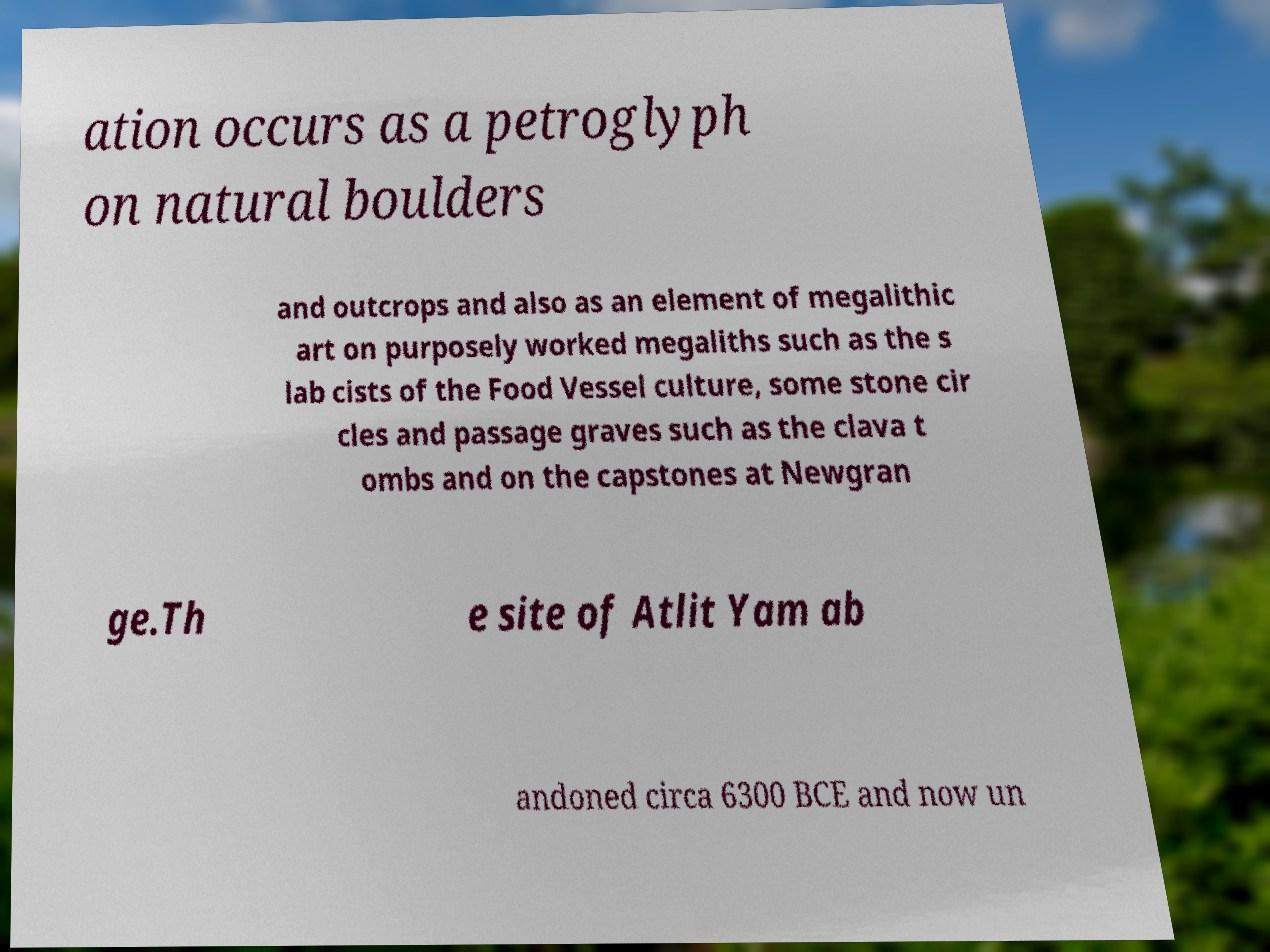Can you accurately transcribe the text from the provided image for me? ation occurs as a petroglyph on natural boulders and outcrops and also as an element of megalithic art on purposely worked megaliths such as the s lab cists of the Food Vessel culture, some stone cir cles and passage graves such as the clava t ombs and on the capstones at Newgran ge.Th e site of Atlit Yam ab andoned circa 6300 BCE and now un 